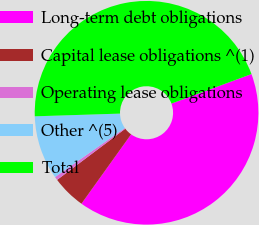Convert chart to OTSL. <chart><loc_0><loc_0><loc_500><loc_500><pie_chart><fcel>Long-term debt obligations<fcel>Capital lease obligations ^(1)<fcel>Operating lease obligations<fcel>Other ^(5)<fcel>Total<nl><fcel>40.51%<fcel>4.87%<fcel>0.5%<fcel>9.24%<fcel>44.88%<nl></chart> 